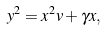<formula> <loc_0><loc_0><loc_500><loc_500>y ^ { 2 } = x ^ { 2 } v + \gamma x ,</formula> 